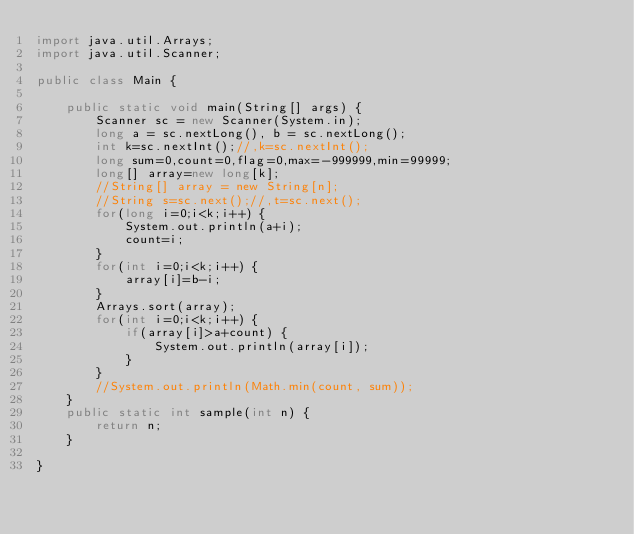Convert code to text. <code><loc_0><loc_0><loc_500><loc_500><_Java_>import java.util.Arrays;
import java.util.Scanner;

public class Main {

	public static void main(String[] args) {
		Scanner sc = new Scanner(System.in);
		long a = sc.nextLong(), b = sc.nextLong();
		int k=sc.nextInt();//,k=sc.nextInt();
		long sum=0,count=0,flag=0,max=-999999,min=99999;
		long[] array=new long[k];
		//String[] array = new String[n];
		//String s=sc.next();//,t=sc.next();
		for(long i=0;i<k;i++) {
			System.out.println(a+i);
			count=i;
		}
		for(int i=0;i<k;i++) {
			array[i]=b-i;
		}
		Arrays.sort(array);
		for(int i=0;i<k;i++) {
			if(array[i]>a+count) {
				System.out.println(array[i]);
			}
		}
		//System.out.println(Math.min(count, sum));
	}
	public static int sample(int n) {
		return n;
	}

}
</code> 